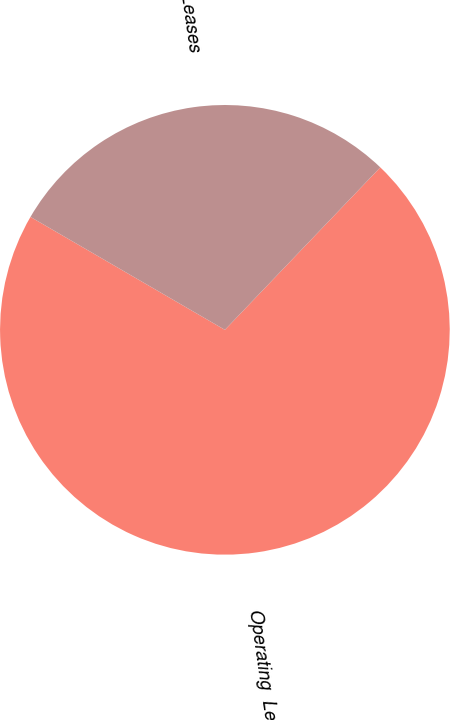<chart> <loc_0><loc_0><loc_500><loc_500><pie_chart><fcel>Operating  Leases<fcel>Capital Leases<nl><fcel>71.23%<fcel>28.77%<nl></chart> 